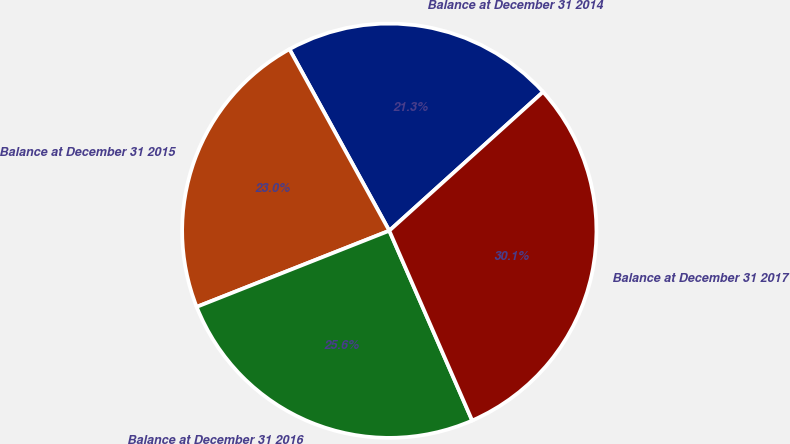<chart> <loc_0><loc_0><loc_500><loc_500><pie_chart><fcel>Balance at December 31 2014<fcel>Balance at December 31 2015<fcel>Balance at December 31 2016<fcel>Balance at December 31 2017<nl><fcel>21.32%<fcel>22.99%<fcel>25.56%<fcel>30.13%<nl></chart> 